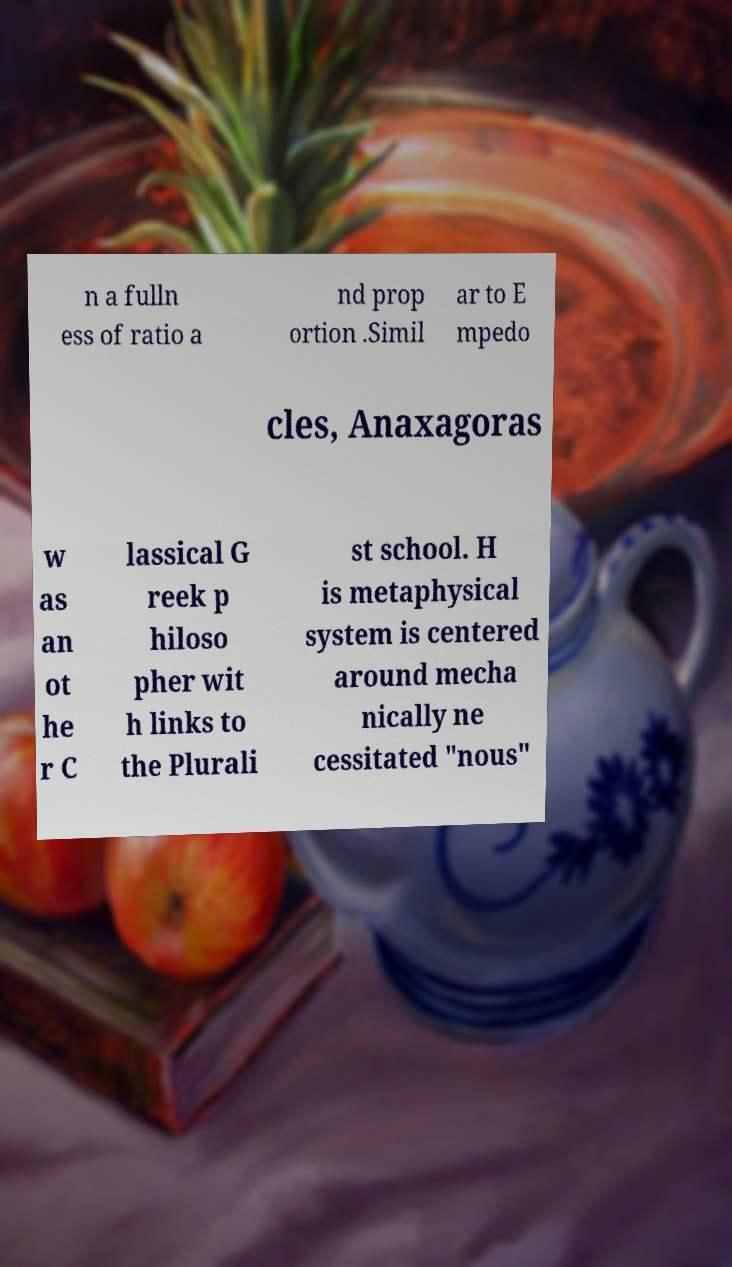There's text embedded in this image that I need extracted. Can you transcribe it verbatim? n a fulln ess of ratio a nd prop ortion .Simil ar to E mpedo cles, Anaxagoras w as an ot he r C lassical G reek p hiloso pher wit h links to the Plurali st school. H is metaphysical system is centered around mecha nically ne cessitated "nous" 